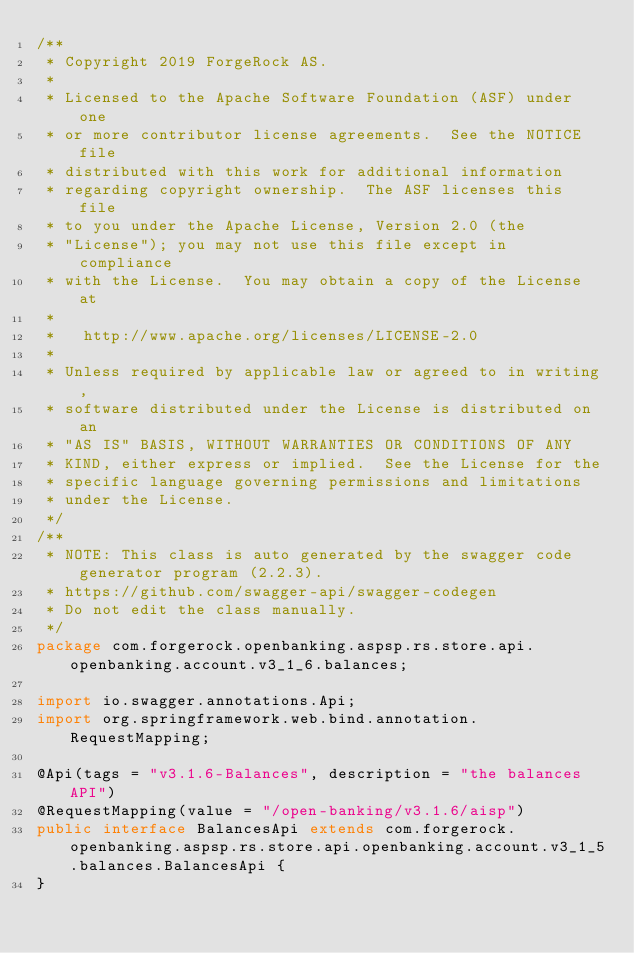<code> <loc_0><loc_0><loc_500><loc_500><_Java_>/**
 * Copyright 2019 ForgeRock AS.
 *
 * Licensed to the Apache Software Foundation (ASF) under one
 * or more contributor license agreements.  See the NOTICE file
 * distributed with this work for additional information
 * regarding copyright ownership.  The ASF licenses this file
 * to you under the Apache License, Version 2.0 (the
 * "License"); you may not use this file except in compliance
 * with the License.  You may obtain a copy of the License at
 *
 *   http://www.apache.org/licenses/LICENSE-2.0
 *
 * Unless required by applicable law or agreed to in writing,
 * software distributed under the License is distributed on an
 * "AS IS" BASIS, WITHOUT WARRANTIES OR CONDITIONS OF ANY
 * KIND, either express or implied.  See the License for the
 * specific language governing permissions and limitations
 * under the License.
 */
/**
 * NOTE: This class is auto generated by the swagger code generator program (2.2.3).
 * https://github.com/swagger-api/swagger-codegen
 * Do not edit the class manually.
 */
package com.forgerock.openbanking.aspsp.rs.store.api.openbanking.account.v3_1_6.balances;

import io.swagger.annotations.Api;
import org.springframework.web.bind.annotation.RequestMapping;

@Api(tags = "v3.1.6-Balances", description = "the balances API")
@RequestMapping(value = "/open-banking/v3.1.6/aisp")
public interface BalancesApi extends com.forgerock.openbanking.aspsp.rs.store.api.openbanking.account.v3_1_5.balances.BalancesApi {
}
</code> 